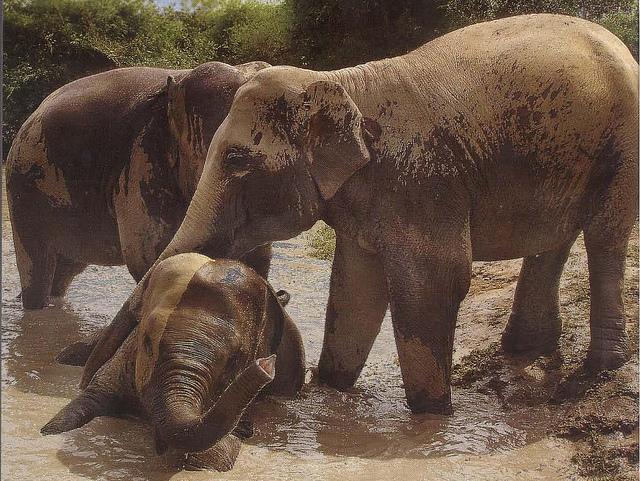Which deity looks like these animals? Please explain your reasoning. ganesh. They are an elephant headed god. 